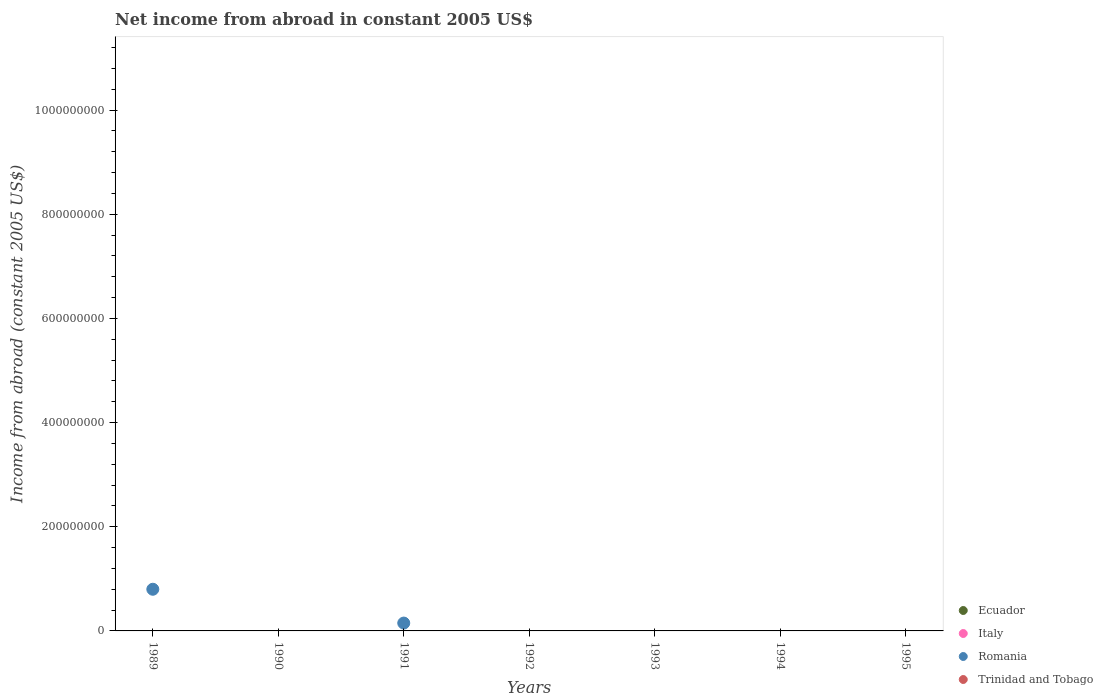How many different coloured dotlines are there?
Offer a very short reply. 1. What is the net income from abroad in Romania in 1991?
Ensure brevity in your answer.  1.51e+07. Across all years, what is the maximum net income from abroad in Romania?
Keep it short and to the point. 8.00e+07. In which year was the net income from abroad in Romania maximum?
Keep it short and to the point. 1989. What is the average net income from abroad in Italy per year?
Give a very brief answer. 0. In how many years, is the net income from abroad in Romania greater than 120000000 US$?
Ensure brevity in your answer.  0. Is it the case that in every year, the sum of the net income from abroad in Italy and net income from abroad in Romania  is greater than the net income from abroad in Ecuador?
Your answer should be very brief. No. Does the net income from abroad in Italy monotonically increase over the years?
Your response must be concise. No. Is the net income from abroad in Italy strictly less than the net income from abroad in Ecuador over the years?
Provide a succinct answer. Yes. How many dotlines are there?
Provide a succinct answer. 1. How many years are there in the graph?
Provide a short and direct response. 7. Are the values on the major ticks of Y-axis written in scientific E-notation?
Keep it short and to the point. No. How many legend labels are there?
Make the answer very short. 4. How are the legend labels stacked?
Ensure brevity in your answer.  Vertical. What is the title of the graph?
Keep it short and to the point. Net income from abroad in constant 2005 US$. What is the label or title of the X-axis?
Give a very brief answer. Years. What is the label or title of the Y-axis?
Ensure brevity in your answer.  Income from abroad (constant 2005 US$). What is the Income from abroad (constant 2005 US$) of Italy in 1989?
Your answer should be compact. 0. What is the Income from abroad (constant 2005 US$) in Romania in 1989?
Ensure brevity in your answer.  8.00e+07. What is the Income from abroad (constant 2005 US$) in Italy in 1990?
Offer a terse response. 0. What is the Income from abroad (constant 2005 US$) of Trinidad and Tobago in 1990?
Give a very brief answer. 0. What is the Income from abroad (constant 2005 US$) in Ecuador in 1991?
Provide a short and direct response. 0. What is the Income from abroad (constant 2005 US$) of Romania in 1991?
Make the answer very short. 1.51e+07. What is the Income from abroad (constant 2005 US$) of Ecuador in 1993?
Offer a very short reply. 0. What is the Income from abroad (constant 2005 US$) in Trinidad and Tobago in 1993?
Keep it short and to the point. 0. What is the Income from abroad (constant 2005 US$) in Italy in 1994?
Provide a succinct answer. 0. What is the Income from abroad (constant 2005 US$) in Trinidad and Tobago in 1994?
Make the answer very short. 0. What is the Income from abroad (constant 2005 US$) in Italy in 1995?
Make the answer very short. 0. What is the Income from abroad (constant 2005 US$) of Romania in 1995?
Your answer should be compact. 0. What is the Income from abroad (constant 2005 US$) in Trinidad and Tobago in 1995?
Offer a very short reply. 0. Across all years, what is the maximum Income from abroad (constant 2005 US$) of Romania?
Offer a very short reply. 8.00e+07. Across all years, what is the minimum Income from abroad (constant 2005 US$) of Romania?
Keep it short and to the point. 0. What is the total Income from abroad (constant 2005 US$) of Ecuador in the graph?
Keep it short and to the point. 0. What is the total Income from abroad (constant 2005 US$) in Italy in the graph?
Ensure brevity in your answer.  0. What is the total Income from abroad (constant 2005 US$) in Romania in the graph?
Ensure brevity in your answer.  9.51e+07. What is the total Income from abroad (constant 2005 US$) in Trinidad and Tobago in the graph?
Give a very brief answer. 0. What is the difference between the Income from abroad (constant 2005 US$) in Romania in 1989 and that in 1991?
Make the answer very short. 6.49e+07. What is the average Income from abroad (constant 2005 US$) in Italy per year?
Give a very brief answer. 0. What is the average Income from abroad (constant 2005 US$) in Romania per year?
Offer a terse response. 1.36e+07. What is the average Income from abroad (constant 2005 US$) of Trinidad and Tobago per year?
Your answer should be compact. 0. What is the ratio of the Income from abroad (constant 2005 US$) of Romania in 1989 to that in 1991?
Provide a short and direct response. 5.31. What is the difference between the highest and the lowest Income from abroad (constant 2005 US$) in Romania?
Your response must be concise. 8.00e+07. 